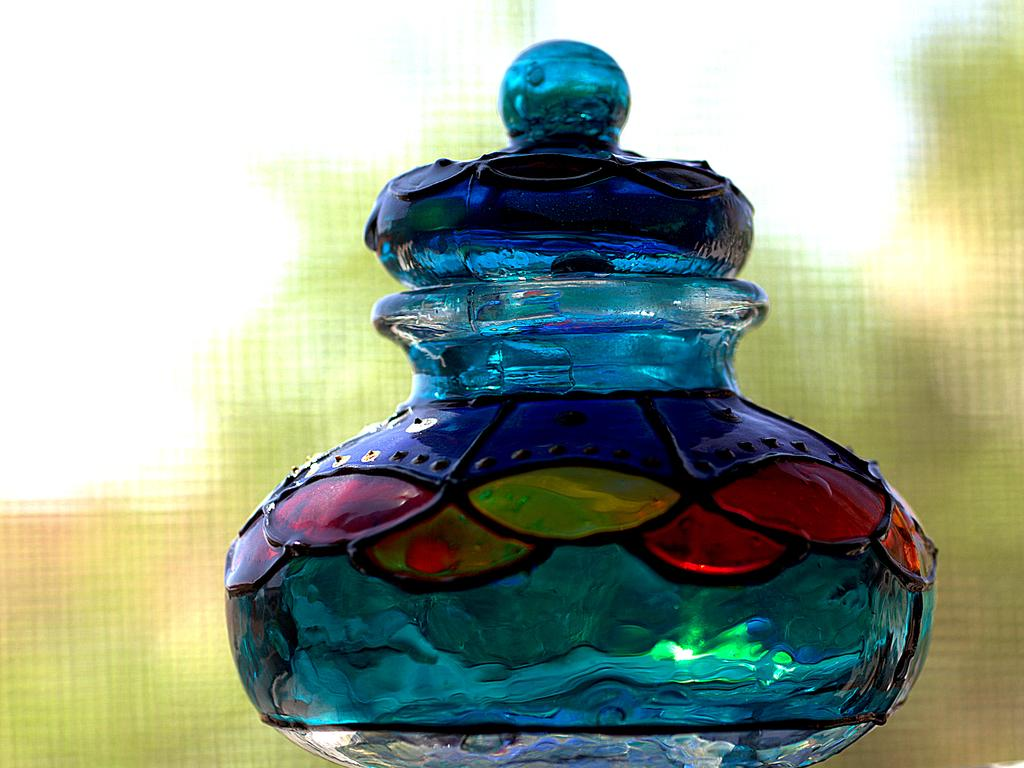What is the main object in the center of the image? There is a glass jar in the center of the image. What is the lid made of? The glass jar has a glass lid. Can you describe the design on the glass jar? Yes, there is a design on the glass jar. How would you describe the background of the image? The background of the image is blurry. How many combs are used to create the design on the glass jar? There are no combs present in the image, and the design on the glass jar is not created using combs. 